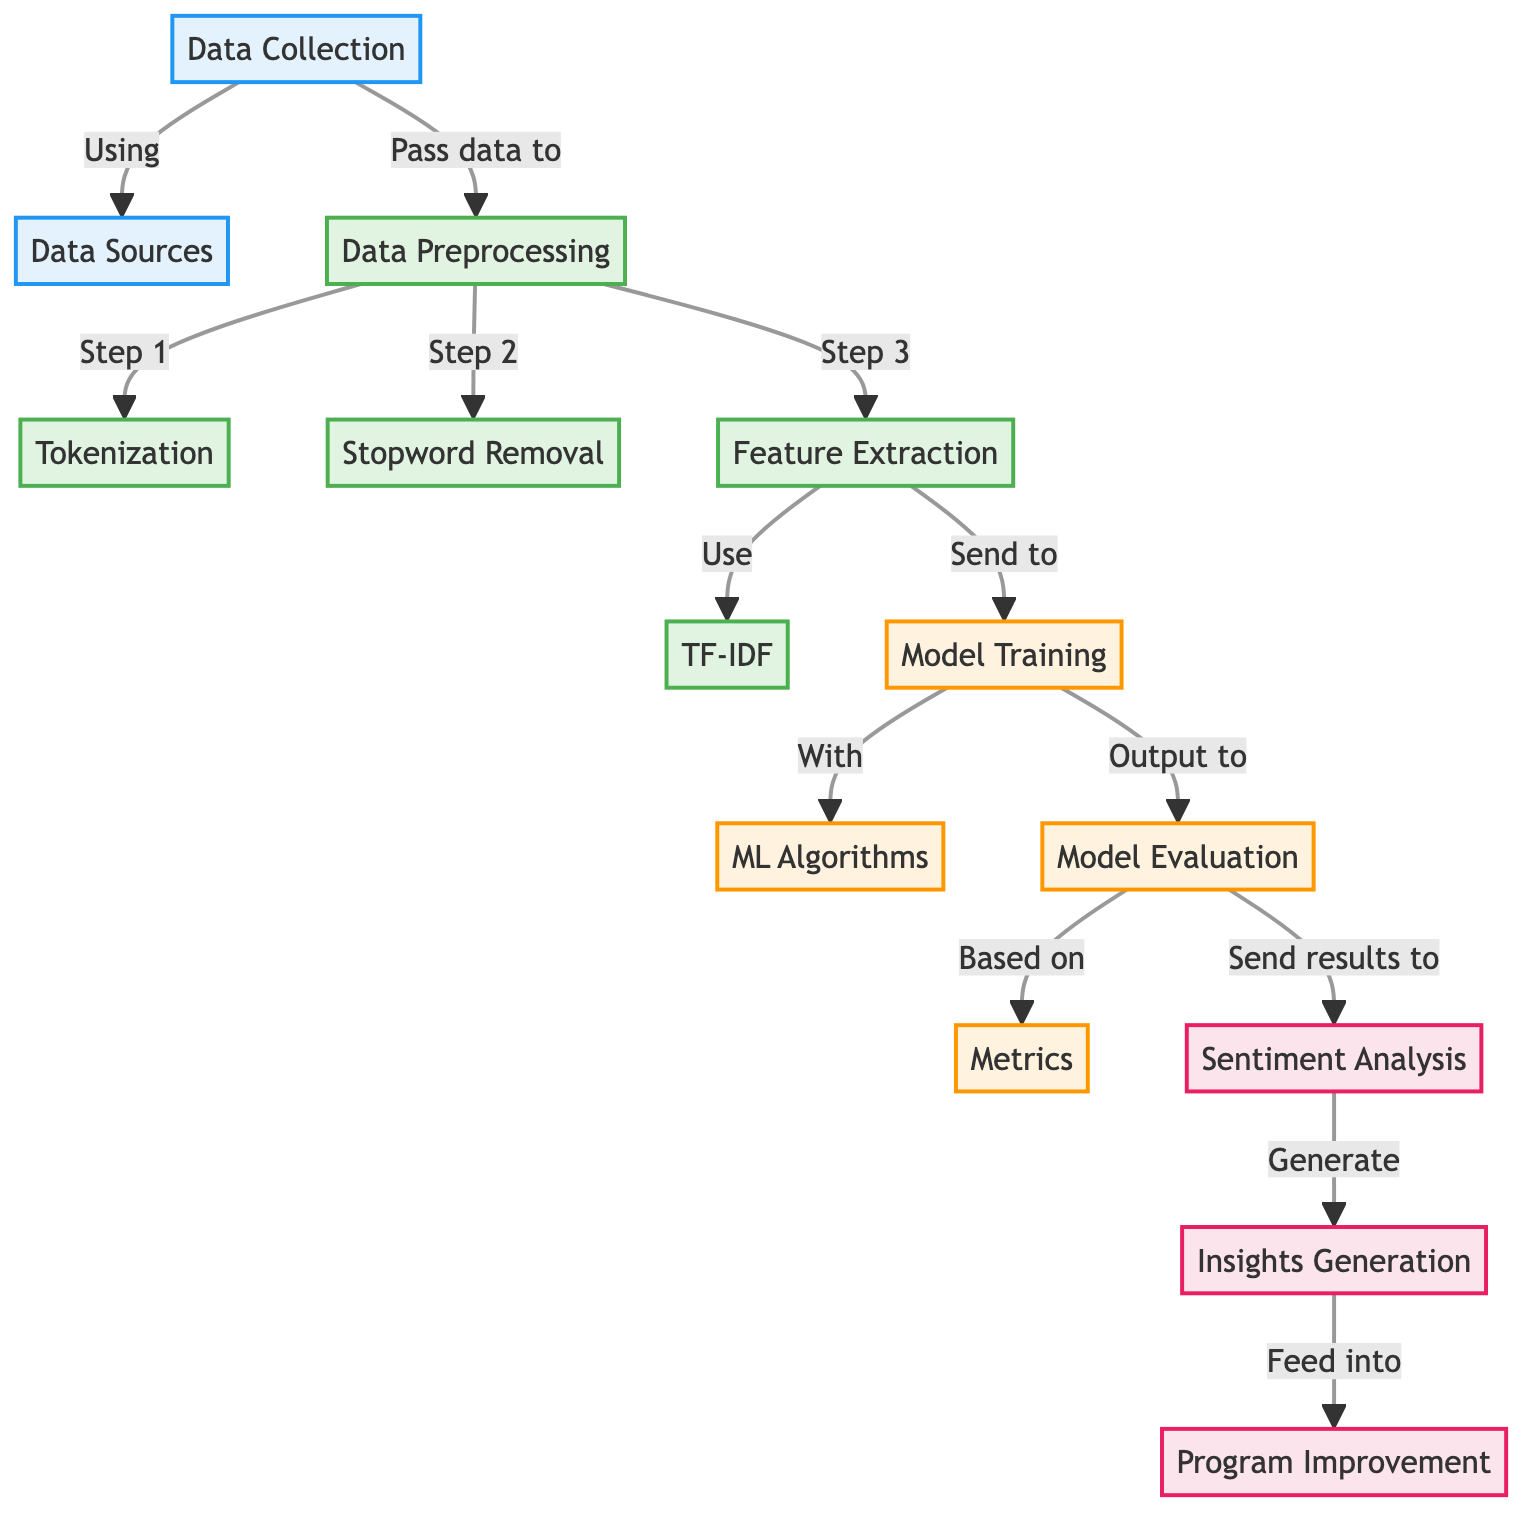What is the first step in the preprocessing section? In the diagram, the first step listed under the preprocessing section is labeled as "Step 1" and is named "Tokenization". Thus, the first preprocessing step is tokenization.
Answer: Tokenization How many steps are in the preprocessing phase? The diagram shows three distinct steps in the preprocessing phase: tokenization, stopword removal, and feature extraction. Counting these steps provides the answer.
Answer: Three Which data preprocessing step uses TF-IDF? The step labeled "Feature Extraction" is indicated to "Use" TF-IDF, which signifies that this specific preprocessing step involves the TF-IDF method.
Answer: Feature Extraction What is the final output of the sentiment analysis process? Following the flow, the final output of the sentiment analysis process is directed towards the "Insights Generation" step, indicating that this is the result after analysis.
Answer: Insights Generation What is the role of metrics in this diagram? In the diagram, "metrics" are shown to be "Based on" the outputs produced from the model evaluation phase. Thus, metrics serve as criteria or benchmarks for evaluating the model's performance.
Answer: Evaluating performance Which two outputs come after model training? According to the diagram, after model training, there are two outputs: model evaluation and insights generation, each leading to different processes within the diagram’s structure.
Answer: Model Evaluation and Insights Generation What is the role of data collection in this diagram? Data collection acts as the initial phase where data is gathered from specific sources, as indicated by its connection to the "Data Sources" node, making it fundamental for the entire process.
Answer: Gather data What does program improvement feed into? The diagram shows that the output of insights generation is directed towards "Program Improvement", which implies that it is influenced or guided by insights obtained from the sentiment analysis.
Answer: Insights Generation 